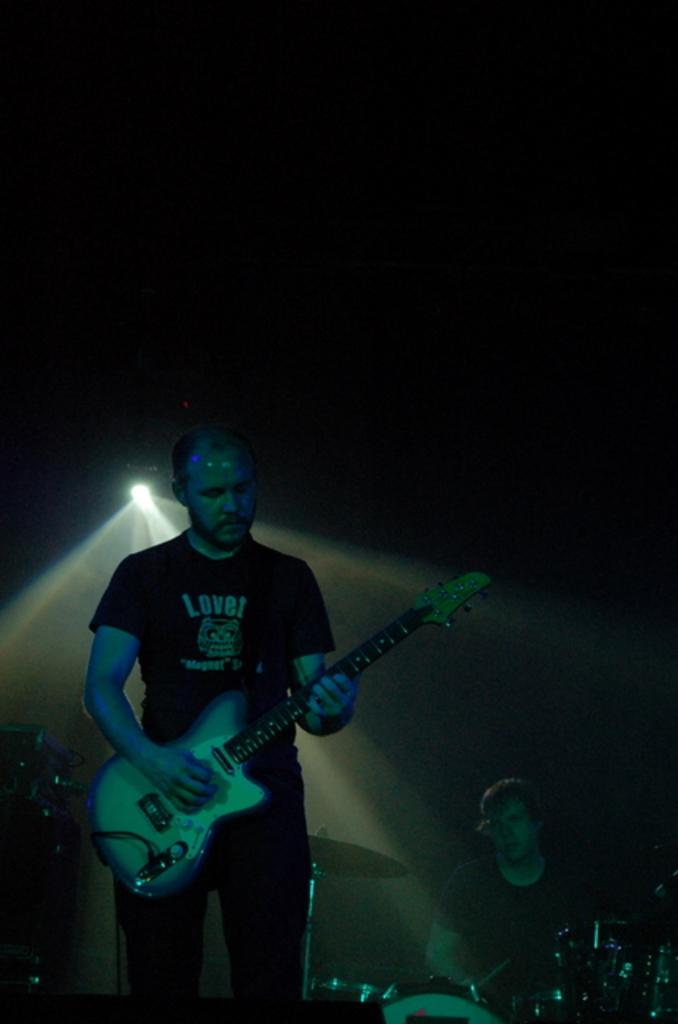What is the person in the image wearing? The person in the image is wearing a black shirt. What is the person doing in the image? The person is playing a guitar. Can you describe the other person in the image? Yes, there is another person in the image, and they are playing drums. What type of fowl can be seen in the image? There is no fowl present in the image. Is this a band performing in the image? The image does not provide enough information to determine if this is a band performing, as it only shows two people playing instruments. 